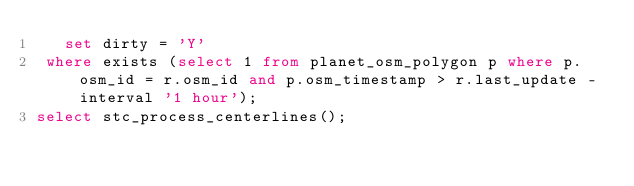<code> <loc_0><loc_0><loc_500><loc_500><_SQL_>   set dirty = 'Y'
 where exists (select 1 from planet_osm_polygon p where p.osm_id = r.osm_id and p.osm_timestamp > r.last_update - interval '1 hour');
select stc_process_centerlines();
</code> 